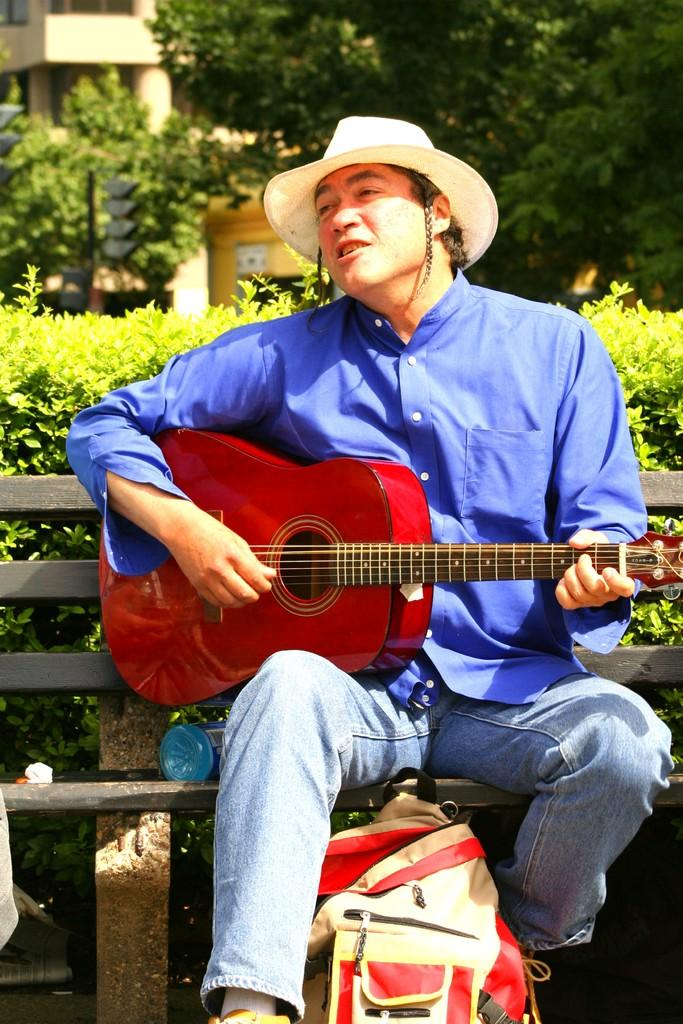What is the person in the image doing? The person is playing a guitar. What is the person sitting on in the image? There is a bench in the image. What can be seen in the background of the image? There is a building, a tree, and plants in the background of the image. Can you see the friend playing the pipe in the image? There is no friend or pipe present in the image. What type of ornament is hanging from the tree in the image? There is no ornament hanging from the tree in the image; only the tree and plants are present in the background. 